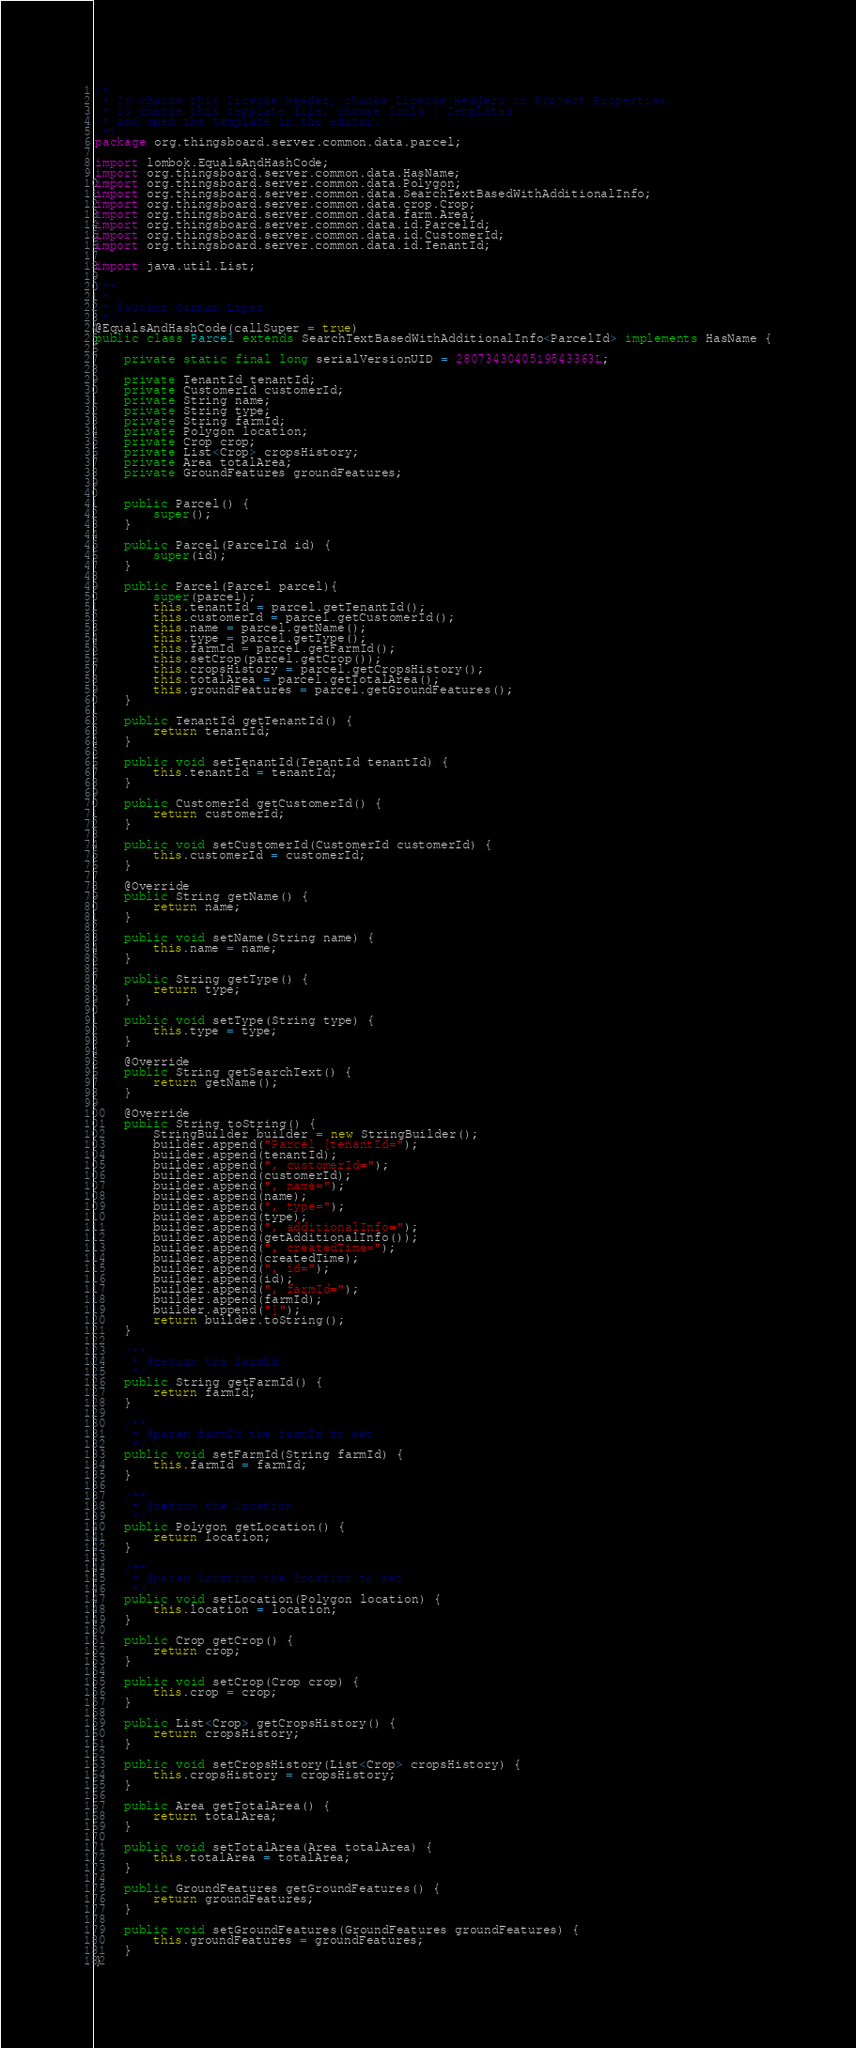Convert code to text. <code><loc_0><loc_0><loc_500><loc_500><_Java_>/*
 * To change this license header, choose License Headers in Project Properties.
 * To change this template file, choose Tools | Templates
 * and open the template in the editor.
 */
package org.thingsboard.server.common.data.parcel;

import lombok.EqualsAndHashCode;
import org.thingsboard.server.common.data.HasName;
import org.thingsboard.server.common.data.Polygon;
import org.thingsboard.server.common.data.SearchTextBasedWithAdditionalInfo;
import org.thingsboard.server.common.data.crop.Crop;
import org.thingsboard.server.common.data.farm.Area;
import org.thingsboard.server.common.data.id.ParcelId;
import org.thingsboard.server.common.data.id.CustomerId;
import org.thingsboard.server.common.data.id.TenantId;

import java.util.List;

/**
 *
 * @author German Lopez
 */
@EqualsAndHashCode(callSuper = true)
public class Parcel extends SearchTextBasedWithAdditionalInfo<ParcelId> implements HasName {

    private static final long serialVersionUID = 2807343040519543363L;

    private TenantId tenantId;
    private CustomerId customerId;
    private String name;
    private String type;
    private String farmId;
    private Polygon location;
    private Crop crop;
    private List<Crop> cropsHistory;
    private Area totalArea;
    private GroundFeatures groundFeatures;


    public Parcel() {
        super();
    }

    public Parcel(ParcelId id) {
        super(id);
    }
    
    public Parcel(Parcel parcel){
        super(parcel);
        this.tenantId = parcel.getTenantId();
        this.customerId = parcel.getCustomerId();
        this.name = parcel.getName();
        this.type = parcel.getType();
        this.farmId = parcel.getFarmId();
        this.setCrop(parcel.getCrop());
        this.cropsHistory = parcel.getCropsHistory();
        this.totalArea = parcel.getTotalArea();
        this.groundFeatures = parcel.getGroundFeatures();
    }

    public TenantId getTenantId() {
        return tenantId;
    }

    public void setTenantId(TenantId tenantId) {
        this.tenantId = tenantId;
    }

    public CustomerId getCustomerId() {
        return customerId;
    }

    public void setCustomerId(CustomerId customerId) {
        this.customerId = customerId;
    }

    @Override
    public String getName() {
        return name;
    }

    public void setName(String name) {
        this.name = name;
    }

    public String getType() {
        return type;
    }

    public void setType(String type) {
        this.type = type;
    }

    @Override
    public String getSearchText() {
        return getName();
    }

    @Override
    public String toString() {
        StringBuilder builder = new StringBuilder();
        builder.append("Parcel [tenantId=");
        builder.append(tenantId);
        builder.append(", customerId=");
        builder.append(customerId);
        builder.append(", name=");
        builder.append(name);
        builder.append(", type=");
        builder.append(type);
        builder.append(", additionalInfo=");
        builder.append(getAdditionalInfo());
        builder.append(", createdTime=");
        builder.append(createdTime);
        builder.append(", id=");
        builder.append(id);
        builder.append(", farmId=");
        builder.append(farmId);
        builder.append("]");
        return builder.toString();
    }

    /**
     * @return the farmId
     */
    public String getFarmId() {
        return farmId;
    }

    /**
     * @param farmId the farmId to set
     */
    public void setFarmId(String farmId) {
        this.farmId = farmId;
    }

    /**
     * @return the location
     */
    public Polygon getLocation() {
        return location;
    }

    /**
     * @param location the location to set
     */
    public void setLocation(Polygon location) {
        this.location = location;
    }

    public Crop getCrop() {
        return crop;
    }

    public void setCrop(Crop crop) {
        this.crop = crop;
    }

    public List<Crop> getCropsHistory() {
        return cropsHistory;
    }

    public void setCropsHistory(List<Crop> cropsHistory) {
        this.cropsHistory = cropsHistory;
    }

    public Area getTotalArea() {
        return totalArea;
    }

    public void setTotalArea(Area totalArea) {
        this.totalArea = totalArea;
    }

    public GroundFeatures getGroundFeatures() {
        return groundFeatures;
    }

    public void setGroundFeatures(GroundFeatures groundFeatures) {
        this.groundFeatures = groundFeatures;
    }
}
</code> 